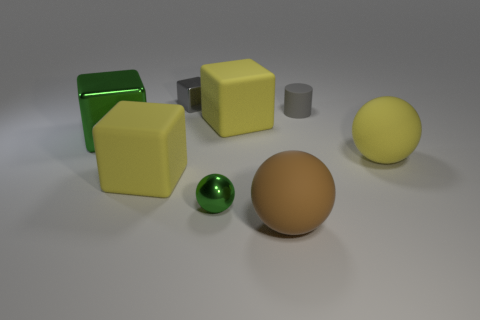The small gray metal object that is behind the green object in front of the big green block is what shape? The small gray metal object located behind the green spherical object and in front of the large green cube is a cylinder. 